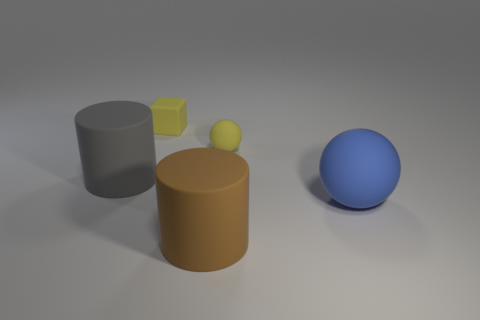What color is the large ball?
Ensure brevity in your answer.  Blue. There is a rubber ball that is behind the blue rubber object; is its size the same as the big gray cylinder?
Your answer should be very brief. No. What is the material of the cylinder behind the matte cylinder that is in front of the large matte cylinder behind the brown thing?
Your answer should be compact. Rubber. Do the big rubber cylinder behind the blue object and the rubber cylinder to the right of the small block have the same color?
Provide a succinct answer. No. What material is the tiny thing that is behind the ball that is on the left side of the blue thing?
Give a very brief answer. Rubber. There is a cylinder that is the same size as the brown thing; what is its color?
Provide a short and direct response. Gray. Do the blue thing and the rubber thing that is to the left of the yellow cube have the same shape?
Keep it short and to the point. No. What is the shape of the tiny object that is the same color as the small cube?
Give a very brief answer. Sphere. There is a ball right of the small matte thing to the right of the cube; how many large brown rubber cylinders are behind it?
Make the answer very short. 0. There is a cylinder that is behind the large ball that is on the right side of the block; how big is it?
Your answer should be compact. Large. 